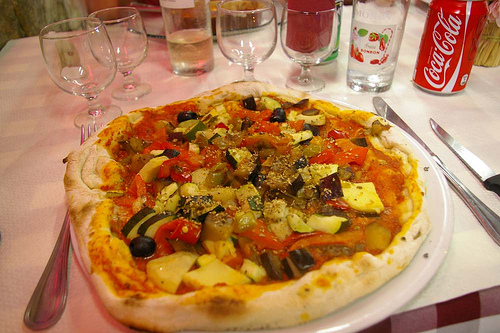What is the vegetable to the right of the utensil on the left? To the right of the utensil on the left, there lies a fresh, crisp squash, ready to be enjoyed. 